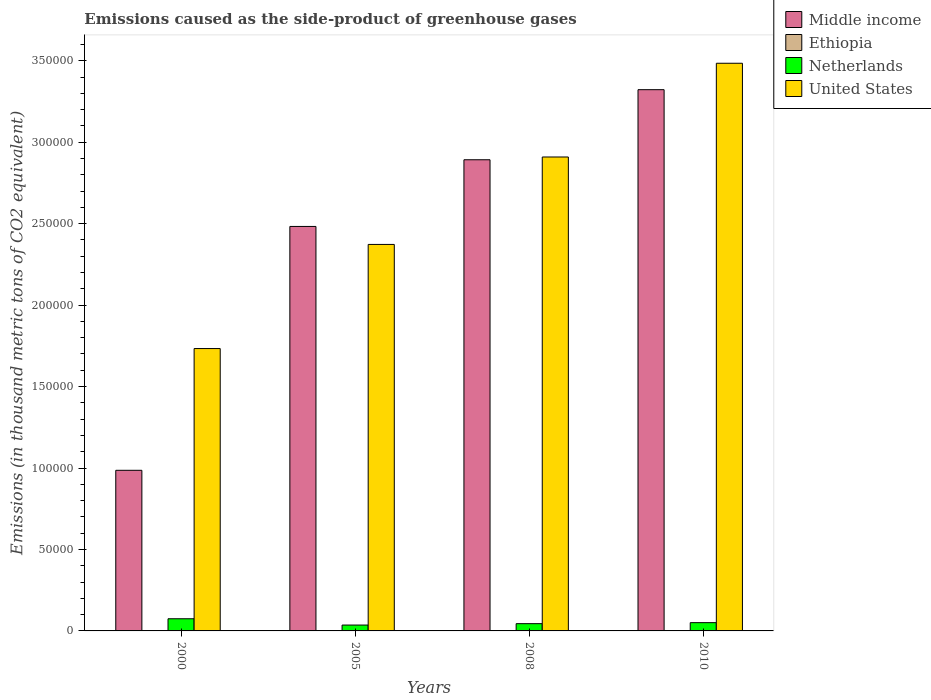How many different coloured bars are there?
Your response must be concise. 4. How many groups of bars are there?
Your response must be concise. 4. How many bars are there on the 2nd tick from the left?
Keep it short and to the point. 4. How many bars are there on the 1st tick from the right?
Offer a very short reply. 4. Across all years, what is the maximum emissions caused as the side-product of greenhouse gases in United States?
Ensure brevity in your answer.  3.48e+05. Across all years, what is the minimum emissions caused as the side-product of greenhouse gases in United States?
Offer a terse response. 1.73e+05. In which year was the emissions caused as the side-product of greenhouse gases in Ethiopia maximum?
Make the answer very short. 2010. What is the total emissions caused as the side-product of greenhouse gases in United States in the graph?
Offer a very short reply. 1.05e+06. What is the difference between the emissions caused as the side-product of greenhouse gases in Netherlands in 2005 and that in 2008?
Your response must be concise. -861.6. What is the difference between the emissions caused as the side-product of greenhouse gases in Middle income in 2000 and the emissions caused as the side-product of greenhouse gases in United States in 2005?
Give a very brief answer. -1.39e+05. What is the average emissions caused as the side-product of greenhouse gases in Middle income per year?
Ensure brevity in your answer.  2.42e+05. In the year 2005, what is the difference between the emissions caused as the side-product of greenhouse gases in United States and emissions caused as the side-product of greenhouse gases in Netherlands?
Ensure brevity in your answer.  2.34e+05. What is the ratio of the emissions caused as the side-product of greenhouse gases in Netherlands in 2000 to that in 2010?
Keep it short and to the point. 1.47. Is the emissions caused as the side-product of greenhouse gases in Netherlands in 2005 less than that in 2010?
Your response must be concise. Yes. What is the difference between the highest and the second highest emissions caused as the side-product of greenhouse gases in United States?
Your response must be concise. 5.75e+04. What is the difference between the highest and the lowest emissions caused as the side-product of greenhouse gases in Middle income?
Make the answer very short. 2.34e+05. What does the 2nd bar from the right in 2008 represents?
Your answer should be compact. Netherlands. Is it the case that in every year, the sum of the emissions caused as the side-product of greenhouse gases in Middle income and emissions caused as the side-product of greenhouse gases in United States is greater than the emissions caused as the side-product of greenhouse gases in Ethiopia?
Give a very brief answer. Yes. How many bars are there?
Provide a short and direct response. 16. What is the difference between two consecutive major ticks on the Y-axis?
Provide a short and direct response. 5.00e+04. Are the values on the major ticks of Y-axis written in scientific E-notation?
Offer a very short reply. No. Does the graph contain any zero values?
Your answer should be compact. No. Does the graph contain grids?
Your answer should be very brief. No. Where does the legend appear in the graph?
Your response must be concise. Top right. What is the title of the graph?
Your answer should be very brief. Emissions caused as the side-product of greenhouse gases. Does "Sint Maarten (Dutch part)" appear as one of the legend labels in the graph?
Your response must be concise. No. What is the label or title of the Y-axis?
Offer a terse response. Emissions (in thousand metric tons of CO2 equivalent). What is the Emissions (in thousand metric tons of CO2 equivalent) of Middle income in 2000?
Make the answer very short. 9.86e+04. What is the Emissions (in thousand metric tons of CO2 equivalent) of Ethiopia in 2000?
Offer a very short reply. 3.6. What is the Emissions (in thousand metric tons of CO2 equivalent) in Netherlands in 2000?
Your response must be concise. 7462.9. What is the Emissions (in thousand metric tons of CO2 equivalent) in United States in 2000?
Provide a succinct answer. 1.73e+05. What is the Emissions (in thousand metric tons of CO2 equivalent) in Middle income in 2005?
Give a very brief answer. 2.48e+05. What is the Emissions (in thousand metric tons of CO2 equivalent) of Ethiopia in 2005?
Your answer should be compact. 10.3. What is the Emissions (in thousand metric tons of CO2 equivalent) in Netherlands in 2005?
Provide a short and direct response. 3597.8. What is the Emissions (in thousand metric tons of CO2 equivalent) of United States in 2005?
Offer a very short reply. 2.37e+05. What is the Emissions (in thousand metric tons of CO2 equivalent) of Middle income in 2008?
Provide a short and direct response. 2.89e+05. What is the Emissions (in thousand metric tons of CO2 equivalent) of Netherlands in 2008?
Your answer should be compact. 4459.4. What is the Emissions (in thousand metric tons of CO2 equivalent) in United States in 2008?
Offer a very short reply. 2.91e+05. What is the Emissions (in thousand metric tons of CO2 equivalent) of Middle income in 2010?
Offer a terse response. 3.32e+05. What is the Emissions (in thousand metric tons of CO2 equivalent) of Netherlands in 2010?
Offer a very short reply. 5074. What is the Emissions (in thousand metric tons of CO2 equivalent) in United States in 2010?
Your answer should be very brief. 3.48e+05. Across all years, what is the maximum Emissions (in thousand metric tons of CO2 equivalent) in Middle income?
Ensure brevity in your answer.  3.32e+05. Across all years, what is the maximum Emissions (in thousand metric tons of CO2 equivalent) of Netherlands?
Ensure brevity in your answer.  7462.9. Across all years, what is the maximum Emissions (in thousand metric tons of CO2 equivalent) of United States?
Offer a very short reply. 3.48e+05. Across all years, what is the minimum Emissions (in thousand metric tons of CO2 equivalent) of Middle income?
Give a very brief answer. 9.86e+04. Across all years, what is the minimum Emissions (in thousand metric tons of CO2 equivalent) of Netherlands?
Provide a short and direct response. 3597.8. Across all years, what is the minimum Emissions (in thousand metric tons of CO2 equivalent) in United States?
Make the answer very short. 1.73e+05. What is the total Emissions (in thousand metric tons of CO2 equivalent) of Middle income in the graph?
Ensure brevity in your answer.  9.68e+05. What is the total Emissions (in thousand metric tons of CO2 equivalent) of Ethiopia in the graph?
Ensure brevity in your answer.  43.2. What is the total Emissions (in thousand metric tons of CO2 equivalent) of Netherlands in the graph?
Keep it short and to the point. 2.06e+04. What is the total Emissions (in thousand metric tons of CO2 equivalent) in United States in the graph?
Provide a short and direct response. 1.05e+06. What is the difference between the Emissions (in thousand metric tons of CO2 equivalent) of Middle income in 2000 and that in 2005?
Provide a succinct answer. -1.50e+05. What is the difference between the Emissions (in thousand metric tons of CO2 equivalent) of Ethiopia in 2000 and that in 2005?
Give a very brief answer. -6.7. What is the difference between the Emissions (in thousand metric tons of CO2 equivalent) of Netherlands in 2000 and that in 2005?
Your response must be concise. 3865.1. What is the difference between the Emissions (in thousand metric tons of CO2 equivalent) of United States in 2000 and that in 2005?
Offer a terse response. -6.39e+04. What is the difference between the Emissions (in thousand metric tons of CO2 equivalent) in Middle income in 2000 and that in 2008?
Make the answer very short. -1.91e+05. What is the difference between the Emissions (in thousand metric tons of CO2 equivalent) in Ethiopia in 2000 and that in 2008?
Offer a terse response. -9.7. What is the difference between the Emissions (in thousand metric tons of CO2 equivalent) of Netherlands in 2000 and that in 2008?
Provide a short and direct response. 3003.5. What is the difference between the Emissions (in thousand metric tons of CO2 equivalent) in United States in 2000 and that in 2008?
Your answer should be compact. -1.18e+05. What is the difference between the Emissions (in thousand metric tons of CO2 equivalent) in Middle income in 2000 and that in 2010?
Your response must be concise. -2.34e+05. What is the difference between the Emissions (in thousand metric tons of CO2 equivalent) in Ethiopia in 2000 and that in 2010?
Offer a very short reply. -12.4. What is the difference between the Emissions (in thousand metric tons of CO2 equivalent) in Netherlands in 2000 and that in 2010?
Your answer should be very brief. 2388.9. What is the difference between the Emissions (in thousand metric tons of CO2 equivalent) of United States in 2000 and that in 2010?
Offer a very short reply. -1.75e+05. What is the difference between the Emissions (in thousand metric tons of CO2 equivalent) in Middle income in 2005 and that in 2008?
Make the answer very short. -4.09e+04. What is the difference between the Emissions (in thousand metric tons of CO2 equivalent) of Netherlands in 2005 and that in 2008?
Offer a very short reply. -861.6. What is the difference between the Emissions (in thousand metric tons of CO2 equivalent) in United States in 2005 and that in 2008?
Keep it short and to the point. -5.37e+04. What is the difference between the Emissions (in thousand metric tons of CO2 equivalent) of Middle income in 2005 and that in 2010?
Your response must be concise. -8.40e+04. What is the difference between the Emissions (in thousand metric tons of CO2 equivalent) of Netherlands in 2005 and that in 2010?
Give a very brief answer. -1476.2. What is the difference between the Emissions (in thousand metric tons of CO2 equivalent) of United States in 2005 and that in 2010?
Provide a succinct answer. -1.11e+05. What is the difference between the Emissions (in thousand metric tons of CO2 equivalent) in Middle income in 2008 and that in 2010?
Provide a succinct answer. -4.30e+04. What is the difference between the Emissions (in thousand metric tons of CO2 equivalent) of Netherlands in 2008 and that in 2010?
Offer a very short reply. -614.6. What is the difference between the Emissions (in thousand metric tons of CO2 equivalent) of United States in 2008 and that in 2010?
Provide a succinct answer. -5.75e+04. What is the difference between the Emissions (in thousand metric tons of CO2 equivalent) of Middle income in 2000 and the Emissions (in thousand metric tons of CO2 equivalent) of Ethiopia in 2005?
Offer a very short reply. 9.86e+04. What is the difference between the Emissions (in thousand metric tons of CO2 equivalent) in Middle income in 2000 and the Emissions (in thousand metric tons of CO2 equivalent) in Netherlands in 2005?
Provide a short and direct response. 9.50e+04. What is the difference between the Emissions (in thousand metric tons of CO2 equivalent) in Middle income in 2000 and the Emissions (in thousand metric tons of CO2 equivalent) in United States in 2005?
Your answer should be very brief. -1.39e+05. What is the difference between the Emissions (in thousand metric tons of CO2 equivalent) in Ethiopia in 2000 and the Emissions (in thousand metric tons of CO2 equivalent) in Netherlands in 2005?
Offer a terse response. -3594.2. What is the difference between the Emissions (in thousand metric tons of CO2 equivalent) of Ethiopia in 2000 and the Emissions (in thousand metric tons of CO2 equivalent) of United States in 2005?
Your answer should be very brief. -2.37e+05. What is the difference between the Emissions (in thousand metric tons of CO2 equivalent) of Netherlands in 2000 and the Emissions (in thousand metric tons of CO2 equivalent) of United States in 2005?
Keep it short and to the point. -2.30e+05. What is the difference between the Emissions (in thousand metric tons of CO2 equivalent) of Middle income in 2000 and the Emissions (in thousand metric tons of CO2 equivalent) of Ethiopia in 2008?
Give a very brief answer. 9.86e+04. What is the difference between the Emissions (in thousand metric tons of CO2 equivalent) in Middle income in 2000 and the Emissions (in thousand metric tons of CO2 equivalent) in Netherlands in 2008?
Offer a very short reply. 9.41e+04. What is the difference between the Emissions (in thousand metric tons of CO2 equivalent) in Middle income in 2000 and the Emissions (in thousand metric tons of CO2 equivalent) in United States in 2008?
Ensure brevity in your answer.  -1.92e+05. What is the difference between the Emissions (in thousand metric tons of CO2 equivalent) of Ethiopia in 2000 and the Emissions (in thousand metric tons of CO2 equivalent) of Netherlands in 2008?
Provide a succinct answer. -4455.8. What is the difference between the Emissions (in thousand metric tons of CO2 equivalent) of Ethiopia in 2000 and the Emissions (in thousand metric tons of CO2 equivalent) of United States in 2008?
Offer a very short reply. -2.91e+05. What is the difference between the Emissions (in thousand metric tons of CO2 equivalent) in Netherlands in 2000 and the Emissions (in thousand metric tons of CO2 equivalent) in United States in 2008?
Your answer should be very brief. -2.83e+05. What is the difference between the Emissions (in thousand metric tons of CO2 equivalent) in Middle income in 2000 and the Emissions (in thousand metric tons of CO2 equivalent) in Ethiopia in 2010?
Offer a very short reply. 9.86e+04. What is the difference between the Emissions (in thousand metric tons of CO2 equivalent) in Middle income in 2000 and the Emissions (in thousand metric tons of CO2 equivalent) in Netherlands in 2010?
Your response must be concise. 9.35e+04. What is the difference between the Emissions (in thousand metric tons of CO2 equivalent) in Middle income in 2000 and the Emissions (in thousand metric tons of CO2 equivalent) in United States in 2010?
Your response must be concise. -2.50e+05. What is the difference between the Emissions (in thousand metric tons of CO2 equivalent) in Ethiopia in 2000 and the Emissions (in thousand metric tons of CO2 equivalent) in Netherlands in 2010?
Offer a terse response. -5070.4. What is the difference between the Emissions (in thousand metric tons of CO2 equivalent) of Ethiopia in 2000 and the Emissions (in thousand metric tons of CO2 equivalent) of United States in 2010?
Offer a very short reply. -3.48e+05. What is the difference between the Emissions (in thousand metric tons of CO2 equivalent) of Netherlands in 2000 and the Emissions (in thousand metric tons of CO2 equivalent) of United States in 2010?
Ensure brevity in your answer.  -3.41e+05. What is the difference between the Emissions (in thousand metric tons of CO2 equivalent) of Middle income in 2005 and the Emissions (in thousand metric tons of CO2 equivalent) of Ethiopia in 2008?
Make the answer very short. 2.48e+05. What is the difference between the Emissions (in thousand metric tons of CO2 equivalent) in Middle income in 2005 and the Emissions (in thousand metric tons of CO2 equivalent) in Netherlands in 2008?
Give a very brief answer. 2.44e+05. What is the difference between the Emissions (in thousand metric tons of CO2 equivalent) of Middle income in 2005 and the Emissions (in thousand metric tons of CO2 equivalent) of United States in 2008?
Ensure brevity in your answer.  -4.26e+04. What is the difference between the Emissions (in thousand metric tons of CO2 equivalent) of Ethiopia in 2005 and the Emissions (in thousand metric tons of CO2 equivalent) of Netherlands in 2008?
Offer a very short reply. -4449.1. What is the difference between the Emissions (in thousand metric tons of CO2 equivalent) in Ethiopia in 2005 and the Emissions (in thousand metric tons of CO2 equivalent) in United States in 2008?
Give a very brief answer. -2.91e+05. What is the difference between the Emissions (in thousand metric tons of CO2 equivalent) of Netherlands in 2005 and the Emissions (in thousand metric tons of CO2 equivalent) of United States in 2008?
Your answer should be very brief. -2.87e+05. What is the difference between the Emissions (in thousand metric tons of CO2 equivalent) in Middle income in 2005 and the Emissions (in thousand metric tons of CO2 equivalent) in Ethiopia in 2010?
Your answer should be very brief. 2.48e+05. What is the difference between the Emissions (in thousand metric tons of CO2 equivalent) of Middle income in 2005 and the Emissions (in thousand metric tons of CO2 equivalent) of Netherlands in 2010?
Your answer should be very brief. 2.43e+05. What is the difference between the Emissions (in thousand metric tons of CO2 equivalent) of Middle income in 2005 and the Emissions (in thousand metric tons of CO2 equivalent) of United States in 2010?
Provide a succinct answer. -1.00e+05. What is the difference between the Emissions (in thousand metric tons of CO2 equivalent) of Ethiopia in 2005 and the Emissions (in thousand metric tons of CO2 equivalent) of Netherlands in 2010?
Make the answer very short. -5063.7. What is the difference between the Emissions (in thousand metric tons of CO2 equivalent) of Ethiopia in 2005 and the Emissions (in thousand metric tons of CO2 equivalent) of United States in 2010?
Your response must be concise. -3.48e+05. What is the difference between the Emissions (in thousand metric tons of CO2 equivalent) in Netherlands in 2005 and the Emissions (in thousand metric tons of CO2 equivalent) in United States in 2010?
Provide a short and direct response. -3.45e+05. What is the difference between the Emissions (in thousand metric tons of CO2 equivalent) of Middle income in 2008 and the Emissions (in thousand metric tons of CO2 equivalent) of Ethiopia in 2010?
Your answer should be very brief. 2.89e+05. What is the difference between the Emissions (in thousand metric tons of CO2 equivalent) in Middle income in 2008 and the Emissions (in thousand metric tons of CO2 equivalent) in Netherlands in 2010?
Provide a short and direct response. 2.84e+05. What is the difference between the Emissions (in thousand metric tons of CO2 equivalent) of Middle income in 2008 and the Emissions (in thousand metric tons of CO2 equivalent) of United States in 2010?
Offer a very short reply. -5.92e+04. What is the difference between the Emissions (in thousand metric tons of CO2 equivalent) in Ethiopia in 2008 and the Emissions (in thousand metric tons of CO2 equivalent) in Netherlands in 2010?
Make the answer very short. -5060.7. What is the difference between the Emissions (in thousand metric tons of CO2 equivalent) in Ethiopia in 2008 and the Emissions (in thousand metric tons of CO2 equivalent) in United States in 2010?
Keep it short and to the point. -3.48e+05. What is the difference between the Emissions (in thousand metric tons of CO2 equivalent) in Netherlands in 2008 and the Emissions (in thousand metric tons of CO2 equivalent) in United States in 2010?
Your answer should be compact. -3.44e+05. What is the average Emissions (in thousand metric tons of CO2 equivalent) in Middle income per year?
Your answer should be compact. 2.42e+05. What is the average Emissions (in thousand metric tons of CO2 equivalent) of Ethiopia per year?
Your response must be concise. 10.8. What is the average Emissions (in thousand metric tons of CO2 equivalent) in Netherlands per year?
Your answer should be compact. 5148.52. What is the average Emissions (in thousand metric tons of CO2 equivalent) of United States per year?
Your response must be concise. 2.62e+05. In the year 2000, what is the difference between the Emissions (in thousand metric tons of CO2 equivalent) in Middle income and Emissions (in thousand metric tons of CO2 equivalent) in Ethiopia?
Offer a very short reply. 9.86e+04. In the year 2000, what is the difference between the Emissions (in thousand metric tons of CO2 equivalent) of Middle income and Emissions (in thousand metric tons of CO2 equivalent) of Netherlands?
Your answer should be compact. 9.11e+04. In the year 2000, what is the difference between the Emissions (in thousand metric tons of CO2 equivalent) in Middle income and Emissions (in thousand metric tons of CO2 equivalent) in United States?
Offer a very short reply. -7.47e+04. In the year 2000, what is the difference between the Emissions (in thousand metric tons of CO2 equivalent) of Ethiopia and Emissions (in thousand metric tons of CO2 equivalent) of Netherlands?
Keep it short and to the point. -7459.3. In the year 2000, what is the difference between the Emissions (in thousand metric tons of CO2 equivalent) of Ethiopia and Emissions (in thousand metric tons of CO2 equivalent) of United States?
Keep it short and to the point. -1.73e+05. In the year 2000, what is the difference between the Emissions (in thousand metric tons of CO2 equivalent) in Netherlands and Emissions (in thousand metric tons of CO2 equivalent) in United States?
Make the answer very short. -1.66e+05. In the year 2005, what is the difference between the Emissions (in thousand metric tons of CO2 equivalent) in Middle income and Emissions (in thousand metric tons of CO2 equivalent) in Ethiopia?
Provide a succinct answer. 2.48e+05. In the year 2005, what is the difference between the Emissions (in thousand metric tons of CO2 equivalent) of Middle income and Emissions (in thousand metric tons of CO2 equivalent) of Netherlands?
Make the answer very short. 2.45e+05. In the year 2005, what is the difference between the Emissions (in thousand metric tons of CO2 equivalent) in Middle income and Emissions (in thousand metric tons of CO2 equivalent) in United States?
Make the answer very short. 1.10e+04. In the year 2005, what is the difference between the Emissions (in thousand metric tons of CO2 equivalent) in Ethiopia and Emissions (in thousand metric tons of CO2 equivalent) in Netherlands?
Make the answer very short. -3587.5. In the year 2005, what is the difference between the Emissions (in thousand metric tons of CO2 equivalent) of Ethiopia and Emissions (in thousand metric tons of CO2 equivalent) of United States?
Keep it short and to the point. -2.37e+05. In the year 2005, what is the difference between the Emissions (in thousand metric tons of CO2 equivalent) in Netherlands and Emissions (in thousand metric tons of CO2 equivalent) in United States?
Provide a short and direct response. -2.34e+05. In the year 2008, what is the difference between the Emissions (in thousand metric tons of CO2 equivalent) of Middle income and Emissions (in thousand metric tons of CO2 equivalent) of Ethiopia?
Offer a terse response. 2.89e+05. In the year 2008, what is the difference between the Emissions (in thousand metric tons of CO2 equivalent) of Middle income and Emissions (in thousand metric tons of CO2 equivalent) of Netherlands?
Your answer should be compact. 2.85e+05. In the year 2008, what is the difference between the Emissions (in thousand metric tons of CO2 equivalent) in Middle income and Emissions (in thousand metric tons of CO2 equivalent) in United States?
Offer a terse response. -1699. In the year 2008, what is the difference between the Emissions (in thousand metric tons of CO2 equivalent) in Ethiopia and Emissions (in thousand metric tons of CO2 equivalent) in Netherlands?
Make the answer very short. -4446.1. In the year 2008, what is the difference between the Emissions (in thousand metric tons of CO2 equivalent) of Ethiopia and Emissions (in thousand metric tons of CO2 equivalent) of United States?
Your response must be concise. -2.91e+05. In the year 2008, what is the difference between the Emissions (in thousand metric tons of CO2 equivalent) of Netherlands and Emissions (in thousand metric tons of CO2 equivalent) of United States?
Ensure brevity in your answer.  -2.86e+05. In the year 2010, what is the difference between the Emissions (in thousand metric tons of CO2 equivalent) in Middle income and Emissions (in thousand metric tons of CO2 equivalent) in Ethiopia?
Offer a very short reply. 3.32e+05. In the year 2010, what is the difference between the Emissions (in thousand metric tons of CO2 equivalent) in Middle income and Emissions (in thousand metric tons of CO2 equivalent) in Netherlands?
Your answer should be compact. 3.27e+05. In the year 2010, what is the difference between the Emissions (in thousand metric tons of CO2 equivalent) of Middle income and Emissions (in thousand metric tons of CO2 equivalent) of United States?
Provide a succinct answer. -1.62e+04. In the year 2010, what is the difference between the Emissions (in thousand metric tons of CO2 equivalent) of Ethiopia and Emissions (in thousand metric tons of CO2 equivalent) of Netherlands?
Provide a succinct answer. -5058. In the year 2010, what is the difference between the Emissions (in thousand metric tons of CO2 equivalent) of Ethiopia and Emissions (in thousand metric tons of CO2 equivalent) of United States?
Offer a very short reply. -3.48e+05. In the year 2010, what is the difference between the Emissions (in thousand metric tons of CO2 equivalent) in Netherlands and Emissions (in thousand metric tons of CO2 equivalent) in United States?
Give a very brief answer. -3.43e+05. What is the ratio of the Emissions (in thousand metric tons of CO2 equivalent) in Middle income in 2000 to that in 2005?
Offer a very short reply. 0.4. What is the ratio of the Emissions (in thousand metric tons of CO2 equivalent) of Ethiopia in 2000 to that in 2005?
Ensure brevity in your answer.  0.35. What is the ratio of the Emissions (in thousand metric tons of CO2 equivalent) of Netherlands in 2000 to that in 2005?
Offer a terse response. 2.07. What is the ratio of the Emissions (in thousand metric tons of CO2 equivalent) of United States in 2000 to that in 2005?
Provide a succinct answer. 0.73. What is the ratio of the Emissions (in thousand metric tons of CO2 equivalent) in Middle income in 2000 to that in 2008?
Keep it short and to the point. 0.34. What is the ratio of the Emissions (in thousand metric tons of CO2 equivalent) of Ethiopia in 2000 to that in 2008?
Your answer should be very brief. 0.27. What is the ratio of the Emissions (in thousand metric tons of CO2 equivalent) of Netherlands in 2000 to that in 2008?
Make the answer very short. 1.67. What is the ratio of the Emissions (in thousand metric tons of CO2 equivalent) in United States in 2000 to that in 2008?
Your response must be concise. 0.6. What is the ratio of the Emissions (in thousand metric tons of CO2 equivalent) of Middle income in 2000 to that in 2010?
Your response must be concise. 0.3. What is the ratio of the Emissions (in thousand metric tons of CO2 equivalent) in Ethiopia in 2000 to that in 2010?
Keep it short and to the point. 0.23. What is the ratio of the Emissions (in thousand metric tons of CO2 equivalent) of Netherlands in 2000 to that in 2010?
Keep it short and to the point. 1.47. What is the ratio of the Emissions (in thousand metric tons of CO2 equivalent) of United States in 2000 to that in 2010?
Your response must be concise. 0.5. What is the ratio of the Emissions (in thousand metric tons of CO2 equivalent) of Middle income in 2005 to that in 2008?
Your answer should be very brief. 0.86. What is the ratio of the Emissions (in thousand metric tons of CO2 equivalent) in Ethiopia in 2005 to that in 2008?
Your response must be concise. 0.77. What is the ratio of the Emissions (in thousand metric tons of CO2 equivalent) in Netherlands in 2005 to that in 2008?
Provide a short and direct response. 0.81. What is the ratio of the Emissions (in thousand metric tons of CO2 equivalent) in United States in 2005 to that in 2008?
Give a very brief answer. 0.82. What is the ratio of the Emissions (in thousand metric tons of CO2 equivalent) in Middle income in 2005 to that in 2010?
Offer a very short reply. 0.75. What is the ratio of the Emissions (in thousand metric tons of CO2 equivalent) of Ethiopia in 2005 to that in 2010?
Offer a terse response. 0.64. What is the ratio of the Emissions (in thousand metric tons of CO2 equivalent) in Netherlands in 2005 to that in 2010?
Give a very brief answer. 0.71. What is the ratio of the Emissions (in thousand metric tons of CO2 equivalent) of United States in 2005 to that in 2010?
Ensure brevity in your answer.  0.68. What is the ratio of the Emissions (in thousand metric tons of CO2 equivalent) of Middle income in 2008 to that in 2010?
Ensure brevity in your answer.  0.87. What is the ratio of the Emissions (in thousand metric tons of CO2 equivalent) in Ethiopia in 2008 to that in 2010?
Offer a terse response. 0.83. What is the ratio of the Emissions (in thousand metric tons of CO2 equivalent) in Netherlands in 2008 to that in 2010?
Make the answer very short. 0.88. What is the ratio of the Emissions (in thousand metric tons of CO2 equivalent) in United States in 2008 to that in 2010?
Your answer should be very brief. 0.83. What is the difference between the highest and the second highest Emissions (in thousand metric tons of CO2 equivalent) in Middle income?
Your response must be concise. 4.30e+04. What is the difference between the highest and the second highest Emissions (in thousand metric tons of CO2 equivalent) of Ethiopia?
Offer a very short reply. 2.7. What is the difference between the highest and the second highest Emissions (in thousand metric tons of CO2 equivalent) in Netherlands?
Provide a short and direct response. 2388.9. What is the difference between the highest and the second highest Emissions (in thousand metric tons of CO2 equivalent) of United States?
Your response must be concise. 5.75e+04. What is the difference between the highest and the lowest Emissions (in thousand metric tons of CO2 equivalent) of Middle income?
Keep it short and to the point. 2.34e+05. What is the difference between the highest and the lowest Emissions (in thousand metric tons of CO2 equivalent) in Ethiopia?
Provide a succinct answer. 12.4. What is the difference between the highest and the lowest Emissions (in thousand metric tons of CO2 equivalent) of Netherlands?
Provide a short and direct response. 3865.1. What is the difference between the highest and the lowest Emissions (in thousand metric tons of CO2 equivalent) of United States?
Offer a terse response. 1.75e+05. 